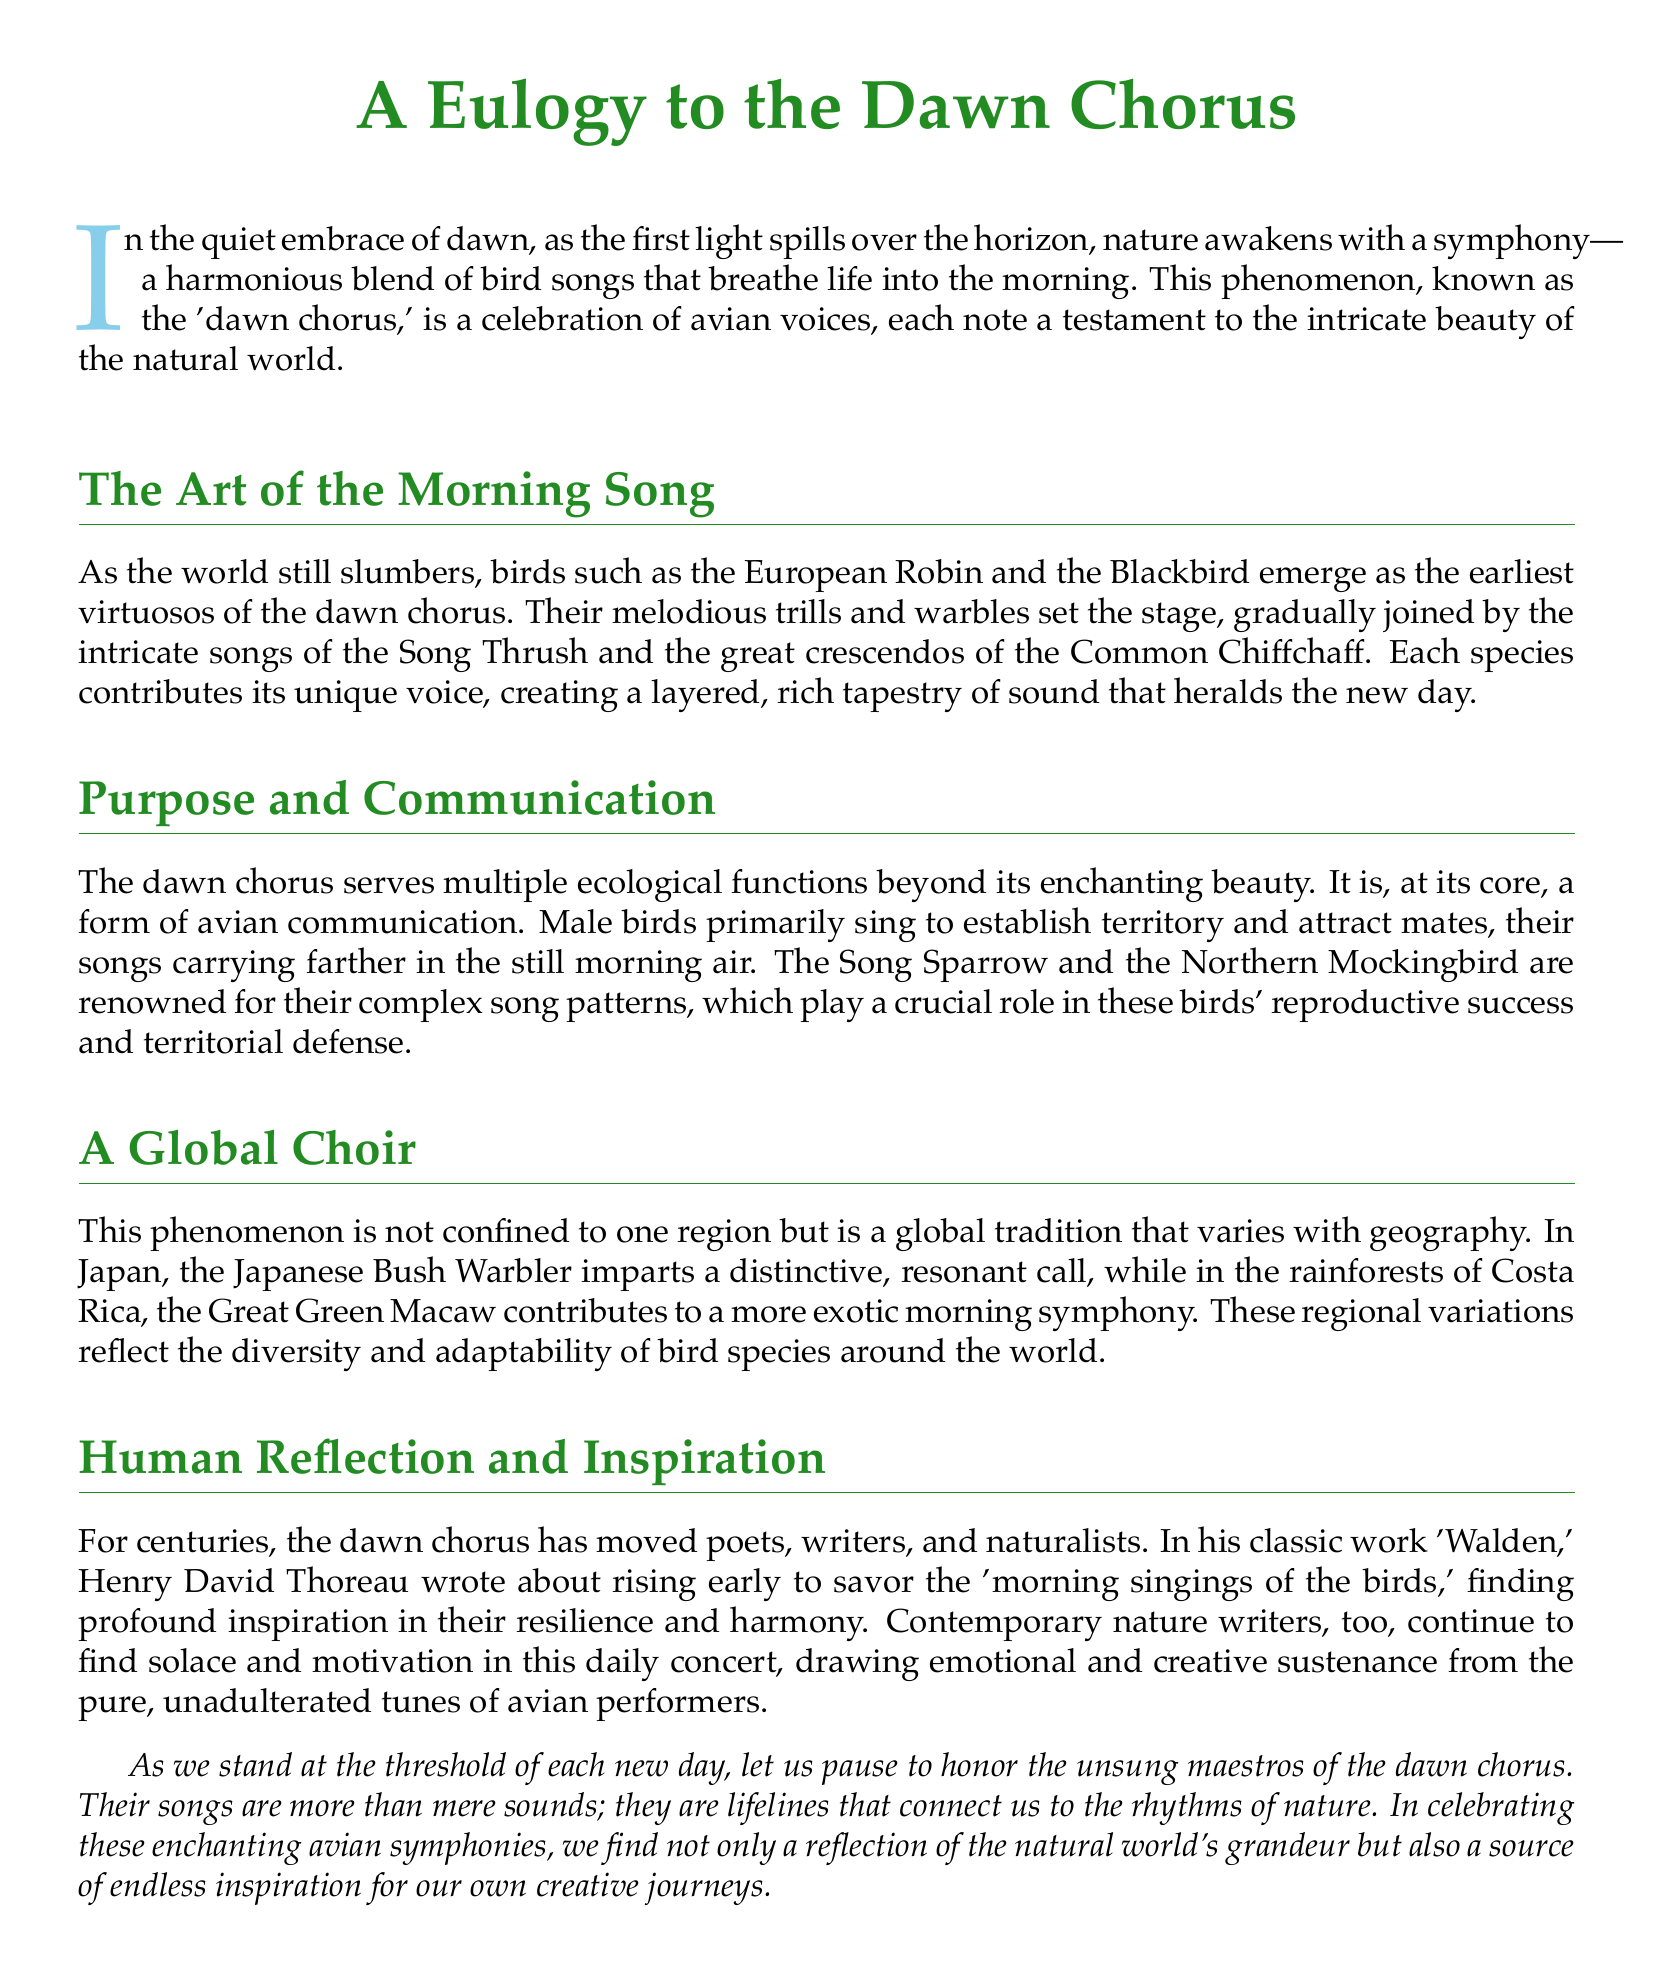What is the title of the eulogy? The title of the eulogy is prominently displayed at the beginning of the document.
Answer: A Eulogy to the Dawn Chorus Which bird is mentioned as one of the earliest performers in the dawn chorus? The document lists birds that initiate the dawn chorus, highlighting their roles.
Answer: European Robin What ecological purpose does the dawn chorus primarily serve? The document explains that the dawn chorus functions as a form of avian communication.
Answer: Communication In which work did Henry David Thoreau write about the morning songs of birds? The text references Thoreau's work that discusses his experiences with nature and bird songs.
Answer: Walden What color is used for the title in the document? The document specifies the color used for the title.
Answer: Nature green Which bird species is renowned for its complex song patterns? The document identifies specific species known for their extraordinary singing abilities.
Answer: Northern Mockingbird How does the dawn chorus vary geographically? The document describes that the dawn chorus is a global tradition with regional variations.
Answer: Regional variations What phrase implies the dawn chorus connects us to nature? The document concludes with a phrase reflecting the significance of bird songs in connecting with nature.
Answer: Lifelines that connect us to the rhythms of nature Who continues to find inspiration in the dawn chorus according to the text? The document mentions contemporary figures who draw motivation from the dawn chorus.
Answer: Contemporary nature writers 